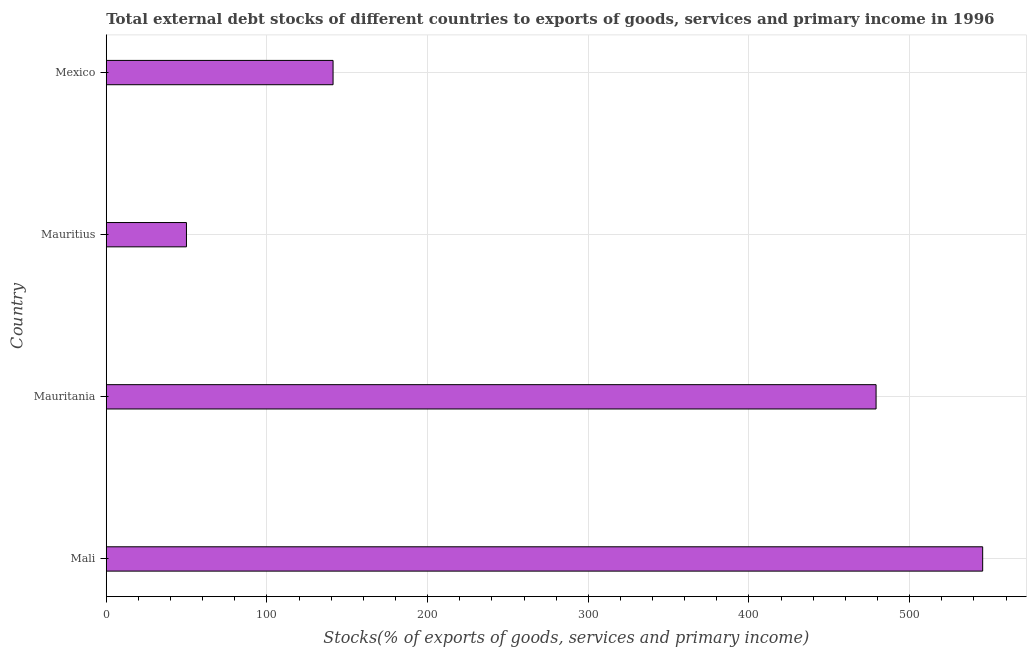Does the graph contain grids?
Offer a very short reply. Yes. What is the title of the graph?
Keep it short and to the point. Total external debt stocks of different countries to exports of goods, services and primary income in 1996. What is the label or title of the X-axis?
Give a very brief answer. Stocks(% of exports of goods, services and primary income). What is the label or title of the Y-axis?
Give a very brief answer. Country. What is the external debt stocks in Mexico?
Make the answer very short. 141.16. Across all countries, what is the maximum external debt stocks?
Your response must be concise. 545.44. Across all countries, what is the minimum external debt stocks?
Offer a very short reply. 49.92. In which country was the external debt stocks maximum?
Offer a terse response. Mali. In which country was the external debt stocks minimum?
Your answer should be compact. Mauritius. What is the sum of the external debt stocks?
Make the answer very short. 1215.62. What is the difference between the external debt stocks in Mauritania and Mauritius?
Your answer should be compact. 429.18. What is the average external debt stocks per country?
Ensure brevity in your answer.  303.91. What is the median external debt stocks?
Your response must be concise. 310.13. What is the ratio of the external debt stocks in Mali to that in Mexico?
Offer a very short reply. 3.86. Is the external debt stocks in Mali less than that in Mauritius?
Keep it short and to the point. No. What is the difference between the highest and the second highest external debt stocks?
Your answer should be very brief. 66.34. Is the sum of the external debt stocks in Mauritania and Mauritius greater than the maximum external debt stocks across all countries?
Keep it short and to the point. No. What is the difference between the highest and the lowest external debt stocks?
Offer a very short reply. 495.52. How many bars are there?
Your answer should be compact. 4. Are all the bars in the graph horizontal?
Offer a terse response. Yes. What is the Stocks(% of exports of goods, services and primary income) of Mali?
Make the answer very short. 545.44. What is the Stocks(% of exports of goods, services and primary income) in Mauritania?
Make the answer very short. 479.1. What is the Stocks(% of exports of goods, services and primary income) of Mauritius?
Offer a very short reply. 49.92. What is the Stocks(% of exports of goods, services and primary income) in Mexico?
Provide a succinct answer. 141.16. What is the difference between the Stocks(% of exports of goods, services and primary income) in Mali and Mauritania?
Keep it short and to the point. 66.34. What is the difference between the Stocks(% of exports of goods, services and primary income) in Mali and Mauritius?
Give a very brief answer. 495.52. What is the difference between the Stocks(% of exports of goods, services and primary income) in Mali and Mexico?
Give a very brief answer. 404.29. What is the difference between the Stocks(% of exports of goods, services and primary income) in Mauritania and Mauritius?
Your response must be concise. 429.18. What is the difference between the Stocks(% of exports of goods, services and primary income) in Mauritania and Mexico?
Give a very brief answer. 337.94. What is the difference between the Stocks(% of exports of goods, services and primary income) in Mauritius and Mexico?
Ensure brevity in your answer.  -91.24. What is the ratio of the Stocks(% of exports of goods, services and primary income) in Mali to that in Mauritania?
Your response must be concise. 1.14. What is the ratio of the Stocks(% of exports of goods, services and primary income) in Mali to that in Mauritius?
Give a very brief answer. 10.93. What is the ratio of the Stocks(% of exports of goods, services and primary income) in Mali to that in Mexico?
Make the answer very short. 3.86. What is the ratio of the Stocks(% of exports of goods, services and primary income) in Mauritania to that in Mauritius?
Your answer should be very brief. 9.6. What is the ratio of the Stocks(% of exports of goods, services and primary income) in Mauritania to that in Mexico?
Make the answer very short. 3.39. What is the ratio of the Stocks(% of exports of goods, services and primary income) in Mauritius to that in Mexico?
Provide a short and direct response. 0.35. 